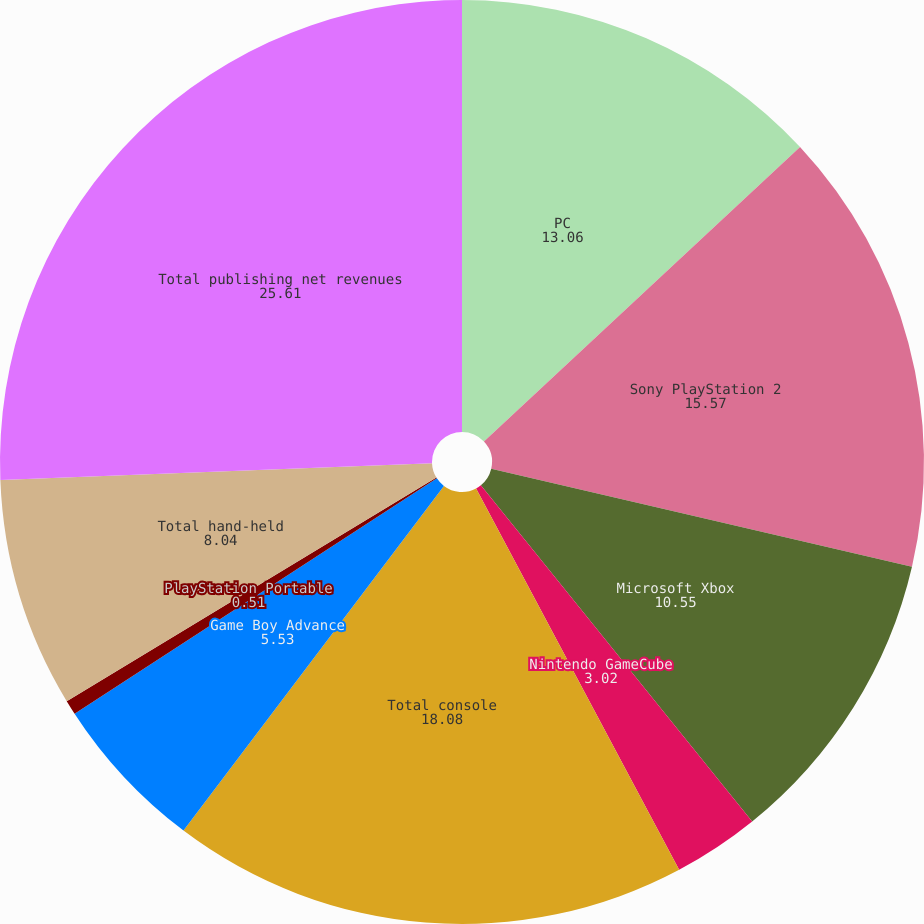Convert chart to OTSL. <chart><loc_0><loc_0><loc_500><loc_500><pie_chart><fcel>PC<fcel>Sony PlayStation 2<fcel>Microsoft Xbox<fcel>Nintendo GameCube<fcel>Total console<fcel>Game Boy Advance<fcel>PlayStation Portable<fcel>Total hand-held<fcel>Total publishing net revenues<nl><fcel>13.06%<fcel>15.57%<fcel>10.55%<fcel>3.02%<fcel>18.08%<fcel>5.53%<fcel>0.51%<fcel>8.04%<fcel>25.61%<nl></chart> 